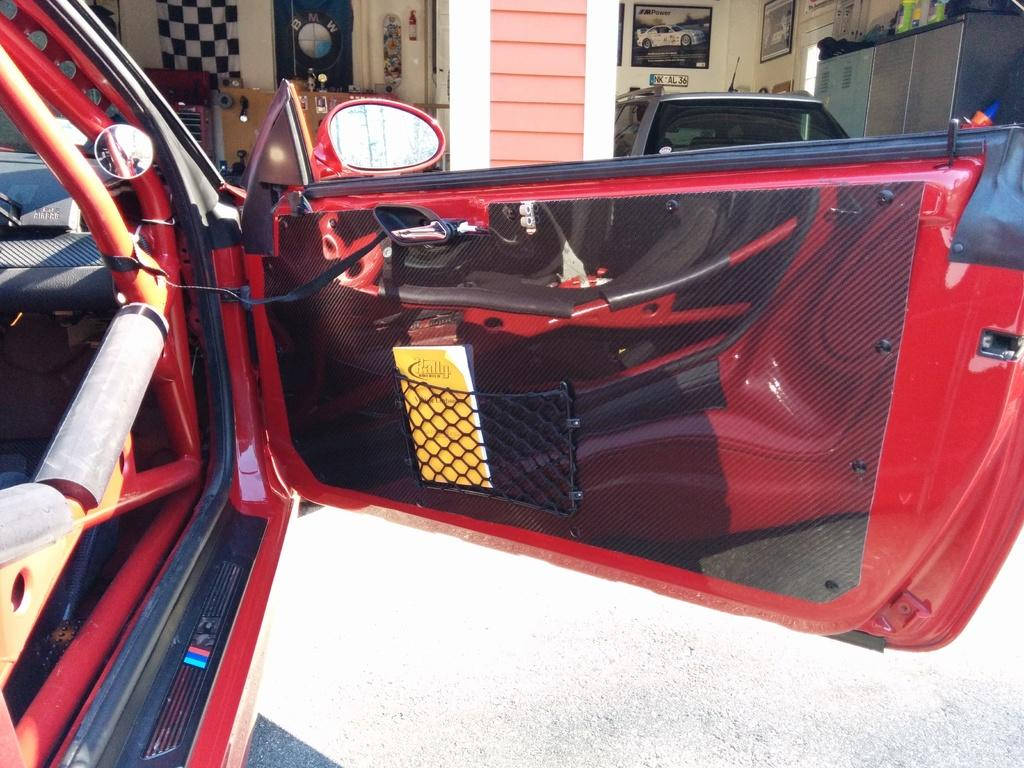What can be seen in the middle of the image? There are two cars in the middle of the image. What is located at the top of the image? There are photo frames on the wall at the top of the image. How many slaves are visible in the image? There are no slaves present in the image. What type of kettle can be seen in the image? There is no kettle present in the image. 